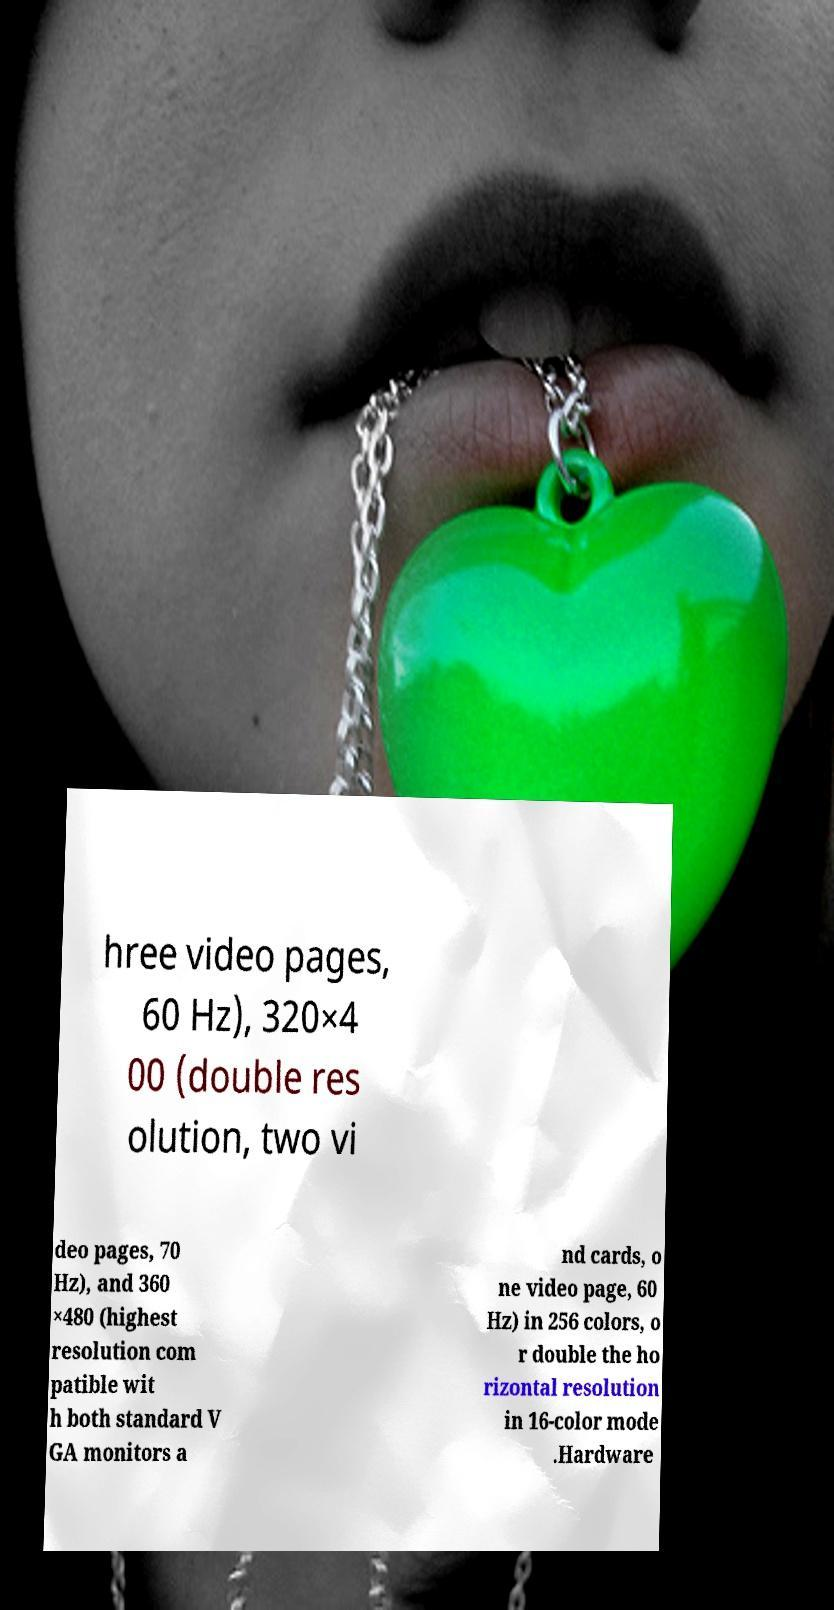Could you assist in decoding the text presented in this image and type it out clearly? hree video pages, 60 Hz), 320×4 00 (double res olution, two vi deo pages, 70 Hz), and 360 ×480 (highest resolution com patible wit h both standard V GA monitors a nd cards, o ne video page, 60 Hz) in 256 colors, o r double the ho rizontal resolution in 16-color mode .Hardware 